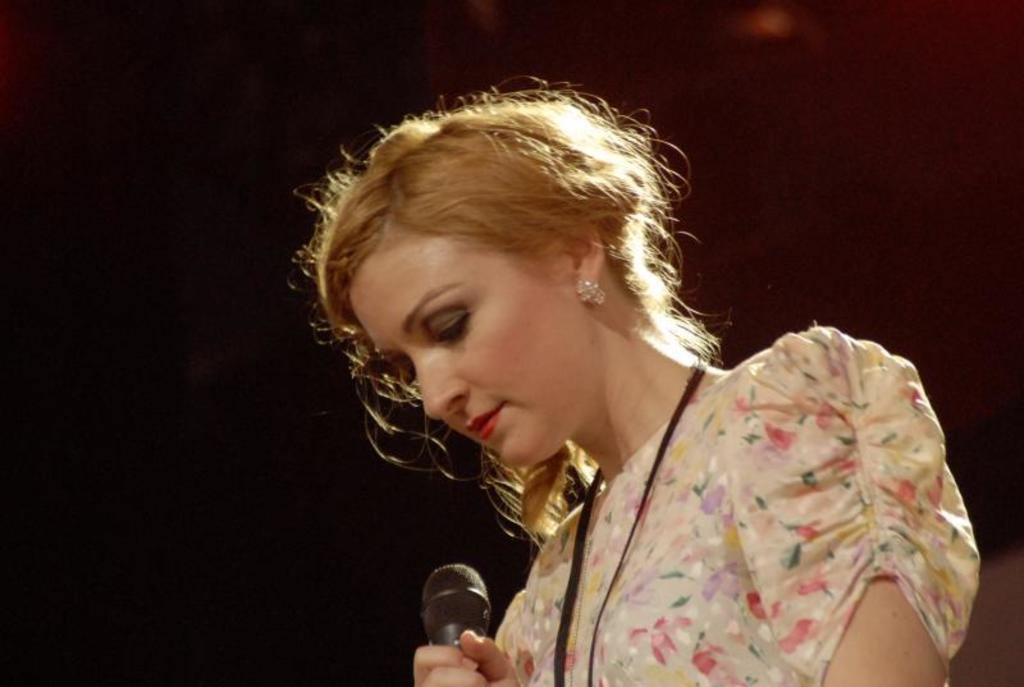Who is the main subject in the image? There is a woman in the image. Where is the woman located in the image? The woman is in the middle of the image. What is the woman holding in her hand? The woman is holding a microphone in her hand. What type of accessories is the woman wearing? The woman has earrings. What type of identification is visible on the woman? The woman is wearing an ID card. What color is the dress the woman is wearing? The woman is wearing a cream-colored dress. Can you see any toads or cattle in the image? No, there are no toads or cattle present in the image. Is the woman at the zoo in the image? There is no information about the location or context of the image, so it cannot be determined if the woman is at a zoo. 